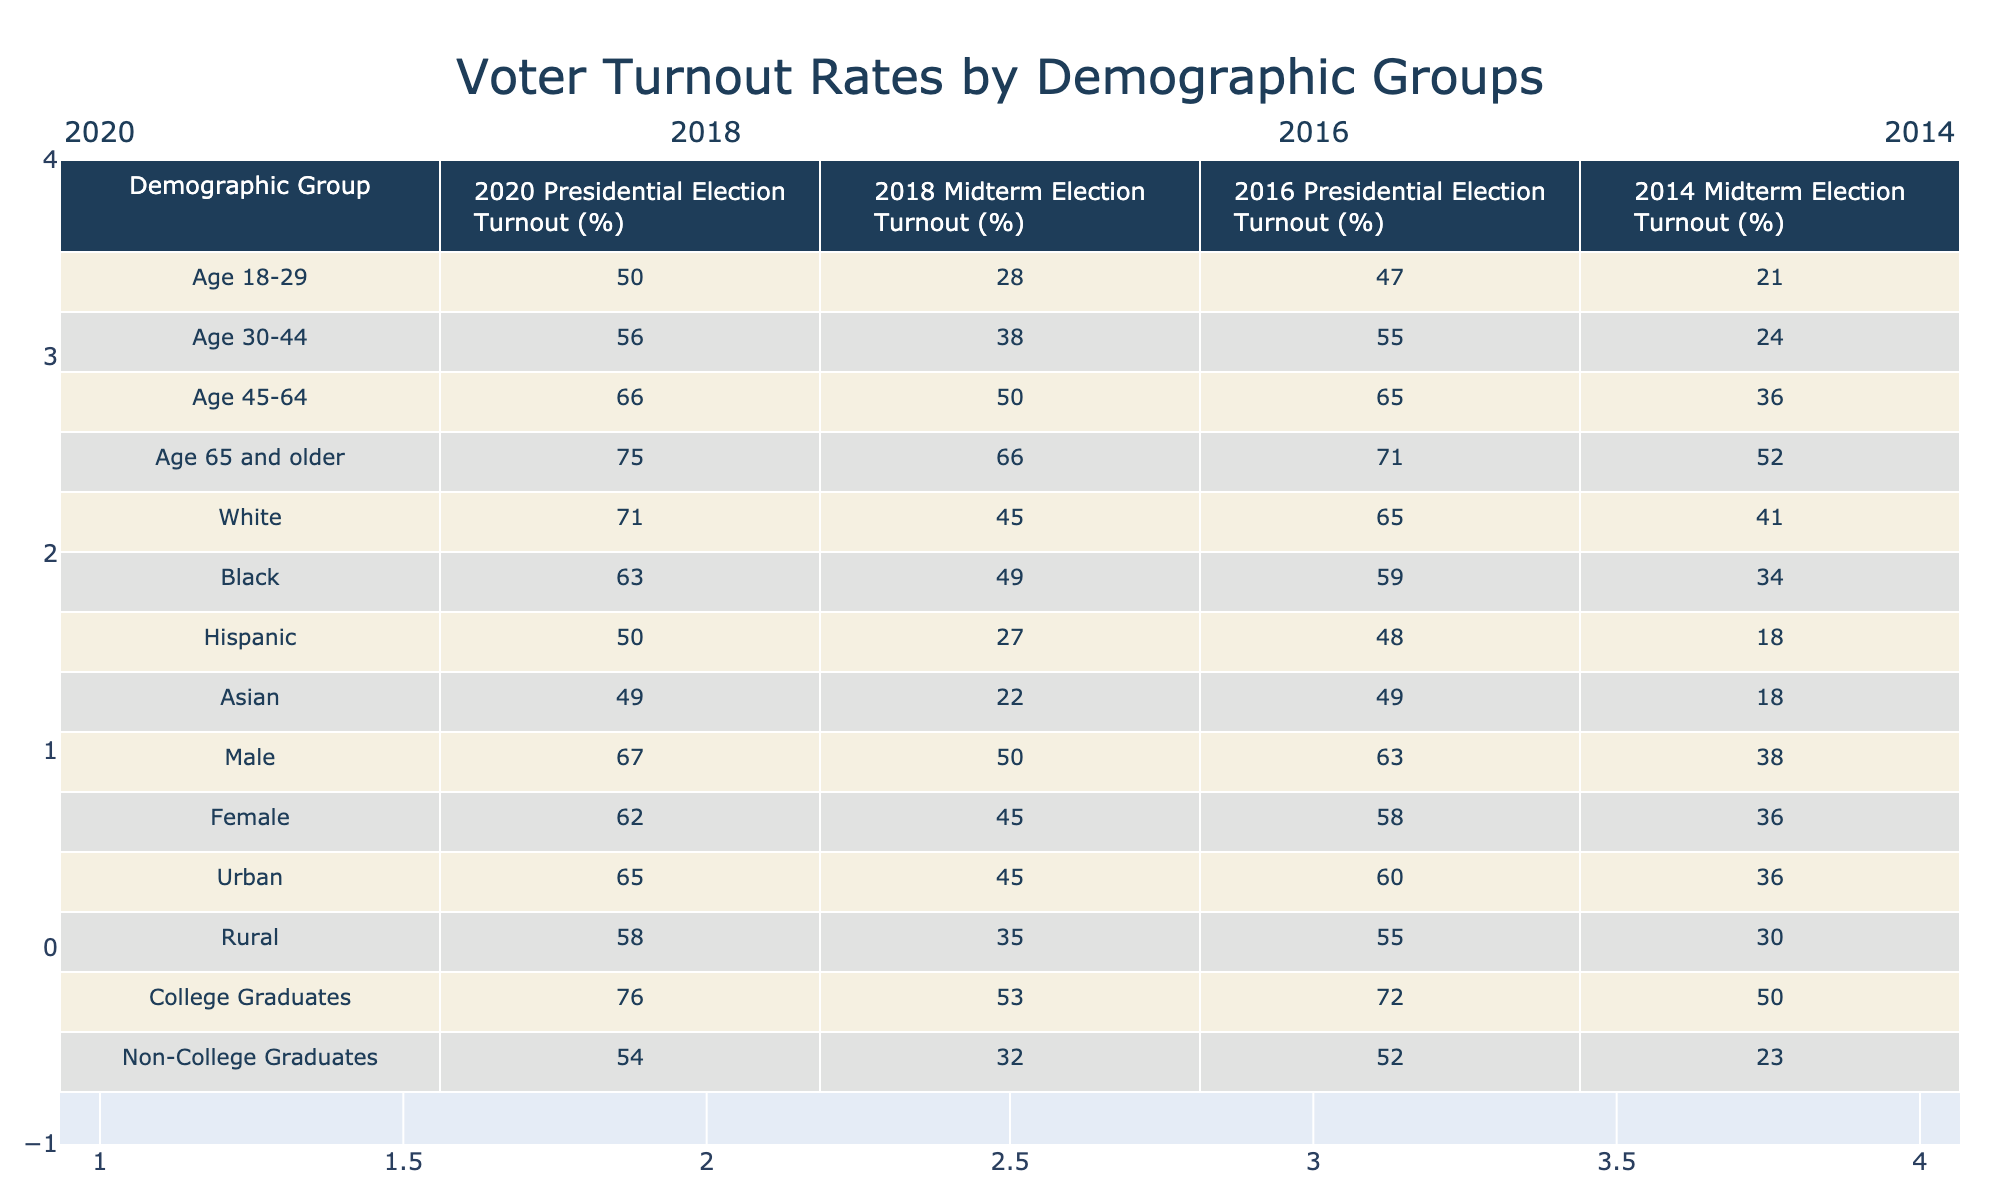What was the voter turnout rate for the age group 18-29 in the 2020 Presidential Election? The table states that the voter turnout rate for the age group 18-29 in the 2020 Presidential Election is 50.0%.
Answer: 50.0% Which demographic group had the highest voter turnout percentage in the 2018 Midterm Election? Looking at the table, the demographic group with the highest voter turnout in the 2018 Midterm Election is Age 65 and older, with a turnout of 66.0%.
Answer: Age 65 and older What is the difference in voter turnout rates between Hispanic voters in the 2020 Presidential Election and 2018 Midterm Election? The voter turnout for Hispanic voters in the 2020 Presidential Election is 50.0%, and in the 2018 Midterm Election, it is 27.0%. The difference is 50.0% - 27.0% = 23.0%.
Answer: 23.0% Did the voter turnout for non-college graduates increase from the 2014 Midterm Election to the 2018 Midterm Election? In the table, the voter turnout for non-college graduates in the 2014 Midterm Election is 23.0% and in the 2018 Midterm Election, it is 32.0%, which shows an increase. Therefore, the answer is yes.
Answer: Yes What was the average voter turnout rate for rural voters across the four elections? The turnout rates for rural voters are 58.0% (2020), 35.0% (2018), 55.0% (2016), and 30.0% (2014). Summing these gives a total of 58.0 + 35.0 + 55.0 + 30.0 = 178.0. Dividing this by 4 yields an average of 178.0 / 4 = 44.5%.
Answer: 44.5% Which age group demonstrated the largest increase in voter turnout from the 2014 Midterm Election to the 2018 Midterm Election? The increases in voter turnout from the 2014 to the 2018 Midterm Election are as follows: Age 18-29: 28.0% - 21.0% = 7.0%, Age 30-44: 38.0% - 24.0% = 14.0%, Age 45-64: 50.0% - 36.0% = 14.0%, Age 65 and older: 66.0% - 52.0% = 14.0%. Here, Age 30-44 shows the largest increase at 14.0%.
Answer: Age 30-44 Is it true that the turnout for female voters in the 2020 Presidential Election was higher than for male voters? The turnout for female voters in the 2020 Presidential Election is 62.0%, while for male voters it is 67.0%. Thus, it is not true that female turnout was higher; it was lower.
Answer: No What is the trend in voter turnout for the age group 45-64 from the 2016 Presidential Election to the 2018 Midterm Election? The table shows that the turnout for the age group 45-64 was 65.0% in the 2016 Presidential Election and dropped to 50.0% in the 2018 Midterm Election, indicating a decline of 15.0%.
Answer: Decline 